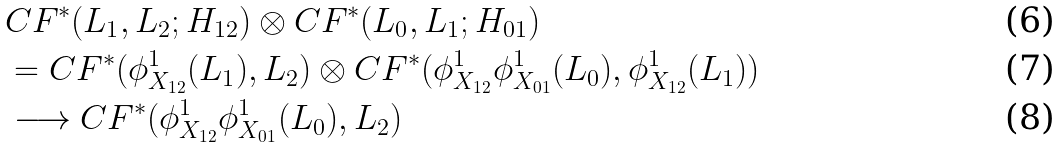Convert formula to latex. <formula><loc_0><loc_0><loc_500><loc_500>& C F ^ { * } ( L _ { 1 } , L _ { 2 } ; H _ { 1 2 } ) \otimes C F ^ { * } ( L _ { 0 } , L _ { 1 } ; H _ { 0 1 } ) \\ & = C F ^ { * } ( \phi _ { X _ { 1 2 } } ^ { 1 } ( L _ { 1 } ) , L _ { 2 } ) \otimes C F ^ { * } ( \phi _ { X _ { 1 2 } } ^ { 1 } \phi _ { X _ { 0 1 } } ^ { 1 } ( L _ { 0 } ) , \phi _ { X _ { 1 2 } } ^ { 1 } ( L _ { 1 } ) ) \\ & \longrightarrow C F ^ { * } ( \phi _ { X _ { 1 2 } } ^ { 1 } \phi _ { X _ { 0 1 } } ^ { 1 } ( L _ { 0 } ) , L _ { 2 } )</formula> 